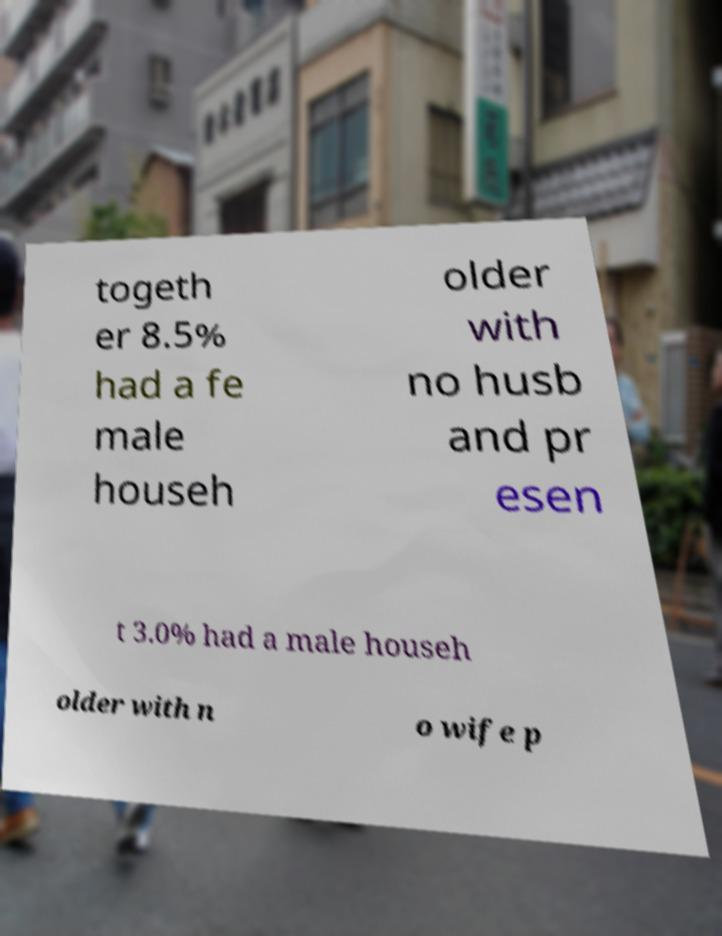For documentation purposes, I need the text within this image transcribed. Could you provide that? togeth er 8.5% had a fe male househ older with no husb and pr esen t 3.0% had a male househ older with n o wife p 